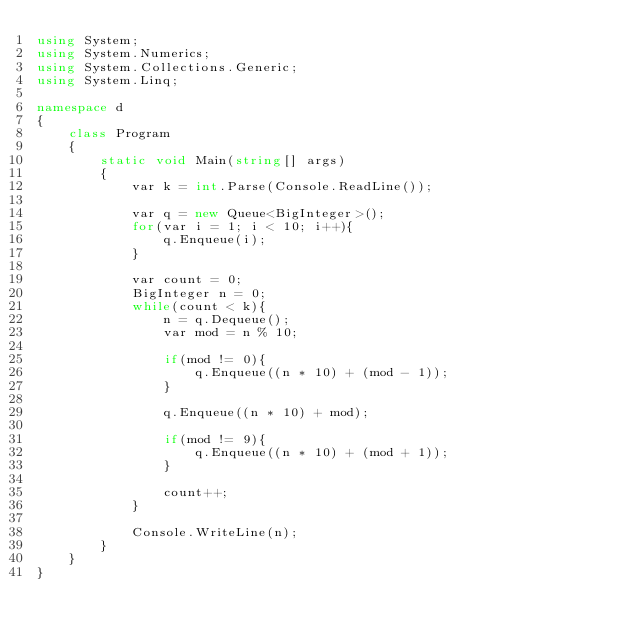Convert code to text. <code><loc_0><loc_0><loc_500><loc_500><_C#_>using System;
using System.Numerics;
using System.Collections.Generic;
using System.Linq;

namespace d
{
    class Program
    {
        static void Main(string[] args)
        {
            var k = int.Parse(Console.ReadLine());

            var q = new Queue<BigInteger>();
            for(var i = 1; i < 10; i++){
                q.Enqueue(i);
            }

            var count = 0;
            BigInteger n = 0;
            while(count < k){
                n = q.Dequeue();
                var mod = n % 10;

                if(mod != 0){
                    q.Enqueue((n * 10) + (mod - 1));
                }

                q.Enqueue((n * 10) + mod);

                if(mod != 9){
                    q.Enqueue((n * 10) + (mod + 1));
                }

                count++;
            }

            Console.WriteLine(n);
        }
    }
}
</code> 